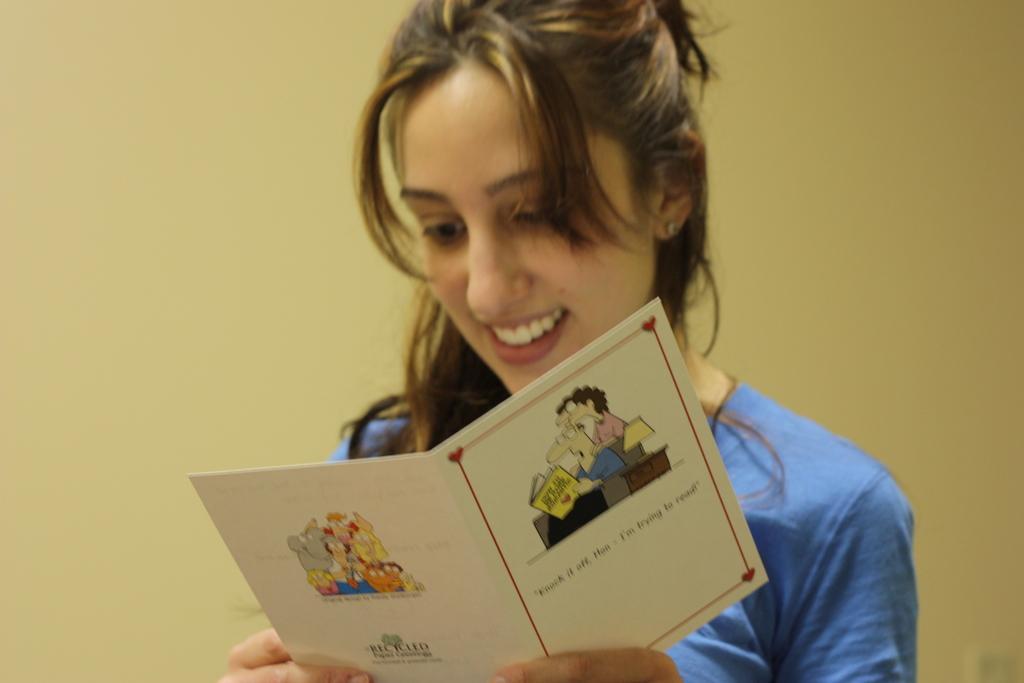Could you give a brief overview of what you see in this image? In the center of the picture there is a woman holding a greeting card, behind her it is wall. 